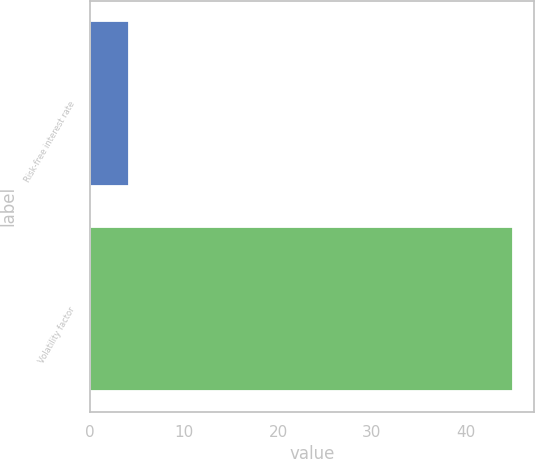Convert chart to OTSL. <chart><loc_0><loc_0><loc_500><loc_500><bar_chart><fcel>Risk-free interest rate<fcel>Volatility factor<nl><fcel>4.16<fcel>45<nl></chart> 